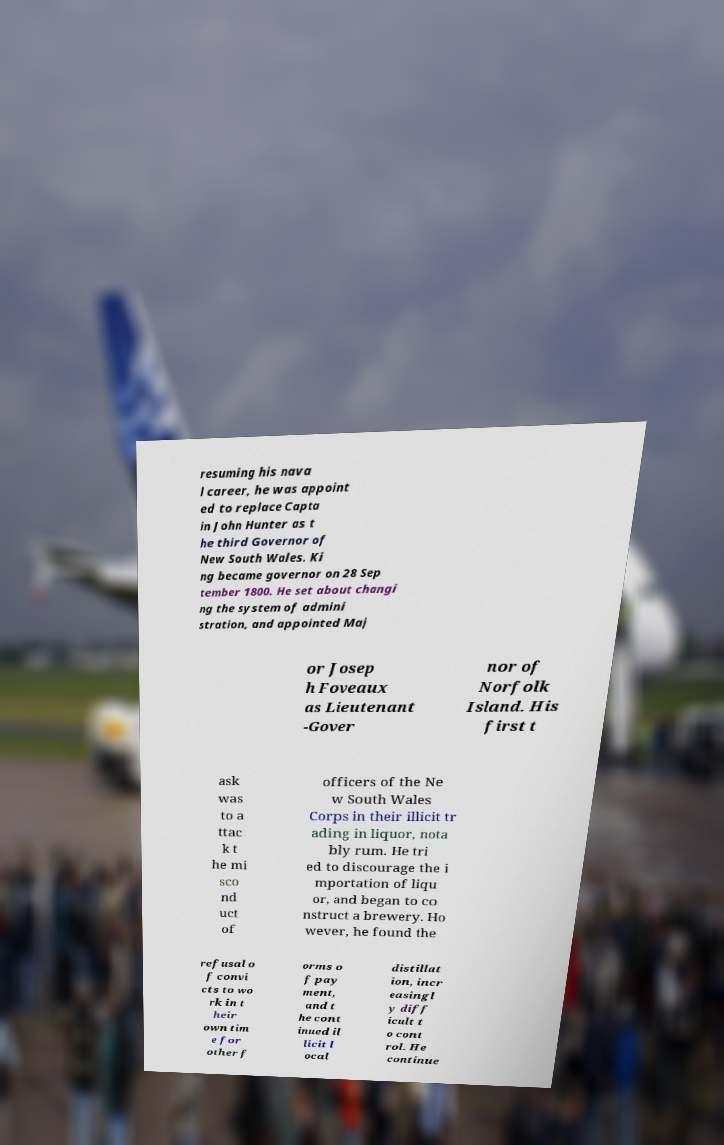Can you read and provide the text displayed in the image?This photo seems to have some interesting text. Can you extract and type it out for me? resuming his nava l career, he was appoint ed to replace Capta in John Hunter as t he third Governor of New South Wales. Ki ng became governor on 28 Sep tember 1800. He set about changi ng the system of admini stration, and appointed Maj or Josep h Foveaux as Lieutenant -Gover nor of Norfolk Island. His first t ask was to a ttac k t he mi sco nd uct of officers of the Ne w South Wales Corps in their illicit tr ading in liquor, nota bly rum. He tri ed to discourage the i mportation of liqu or, and began to co nstruct a brewery. Ho wever, he found the refusal o f convi cts to wo rk in t heir own tim e for other f orms o f pay ment, and t he cont inued il licit l ocal distillat ion, incr easingl y diff icult t o cont rol. He continue 